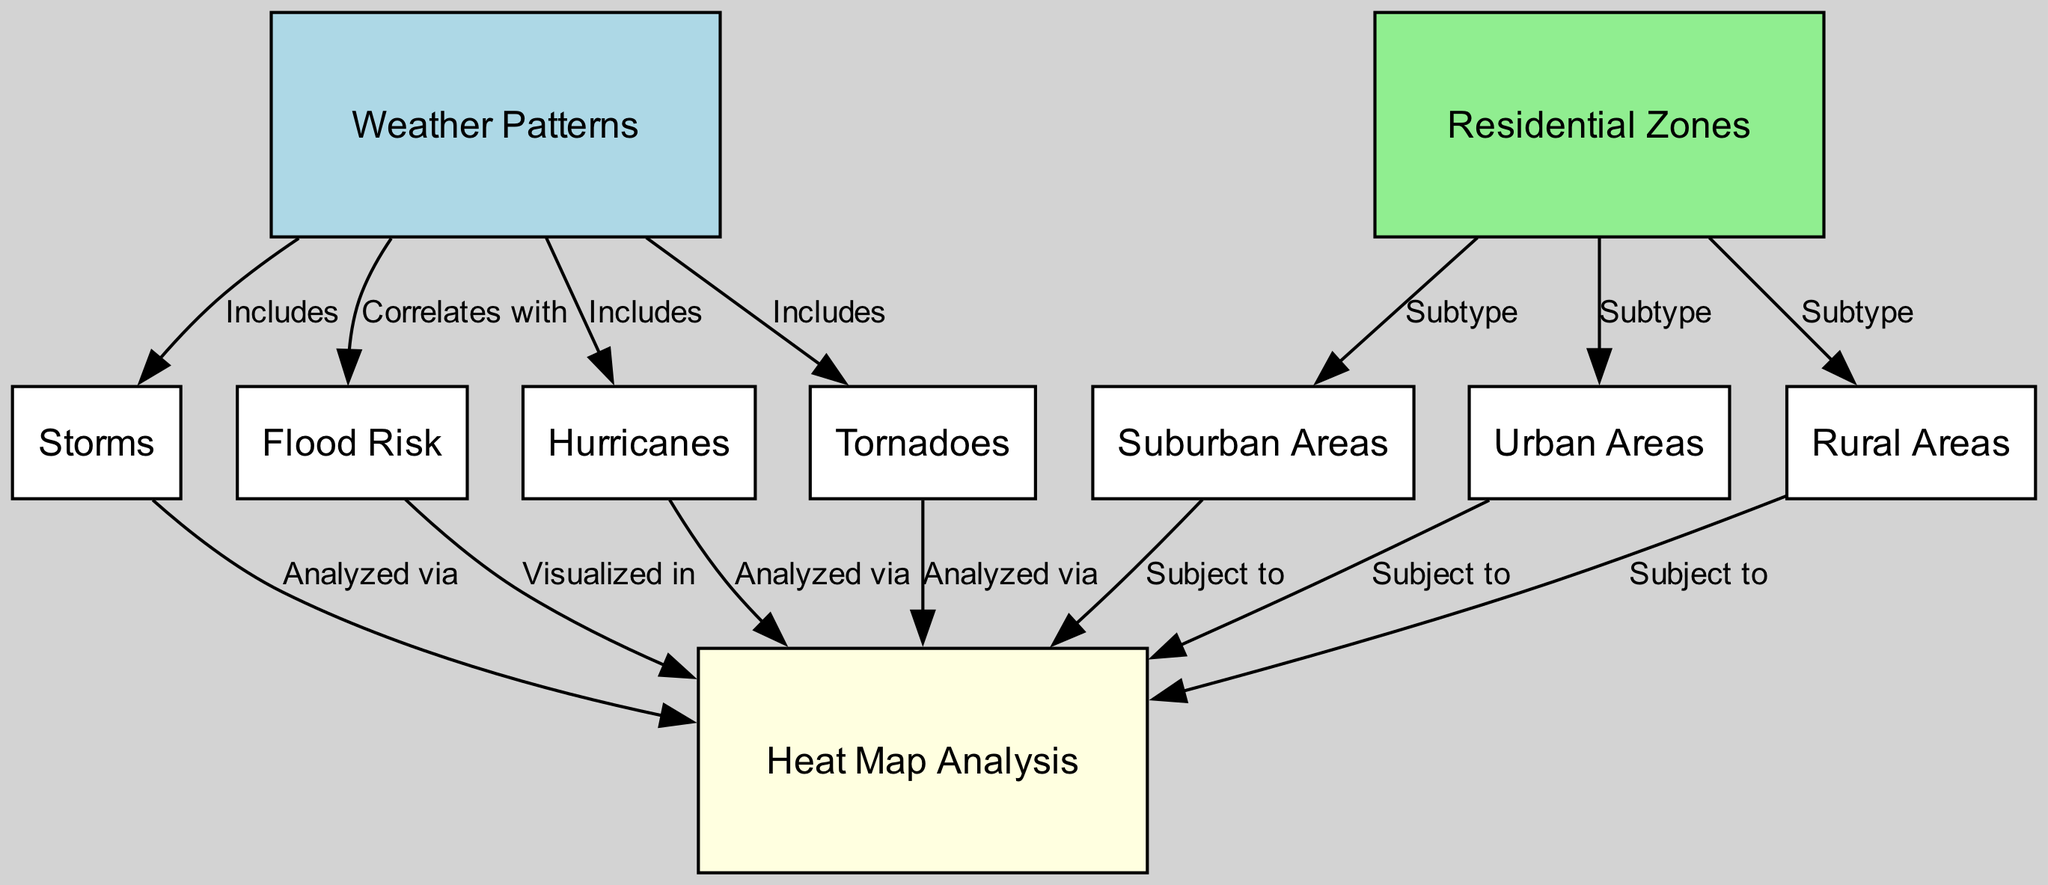What are the subtypes of residential zones? The diagram shows three subtypes of residential zones, they are suburban areas, urban areas, and rural areas, which are all connected to the residential zones node.
Answer: suburban areas, urban areas, rural areas What weather patterns are included in the diagram? The weather patterns node connects to four types of weather phenomena: storms, hurricanes, tornadoes, and flood risk. Thus, all these are included under weather patterns.
Answer: storms, hurricanes, tornadoes How many nodes are there in total? Counting the nodes listed in the data, we find there are 10 distinct nodes present in the diagram.
Answer: 10 What type of analysis is used to visualize flood risk? The edge connecting flood risk to heat map analysis indicates that flood risk is visualized in heat map analysis.
Answer: visualized in Which residential areas are subject to heat map analysis? The diagram lists suburban areas, urban areas, and rural areas as all subject to heat map analysis, linked to it with edges.
Answer: suburban areas, urban areas, rural areas What types of storms are analyzed via heat map analysis? The diagram connects the storms, hurricanes, and tornadoes to heat map analysis, indicating these specific categories of storms are analyzed by it.
Answer: storms, hurricanes, tornadoes What is the relationship between weather patterns and flood risk? In the diagram, a direct correlation edge is drawn from weather patterns to flood risk, indicating that they are correlated with each other.
Answer: correlates with How many edges connect to heat map analysis? Upon examining the diagram, we can see that heat map analysis is connected by five edges to various nodes including storms, flood risk, hurricanes, tornadoes, and residential areas.
Answer: 5 